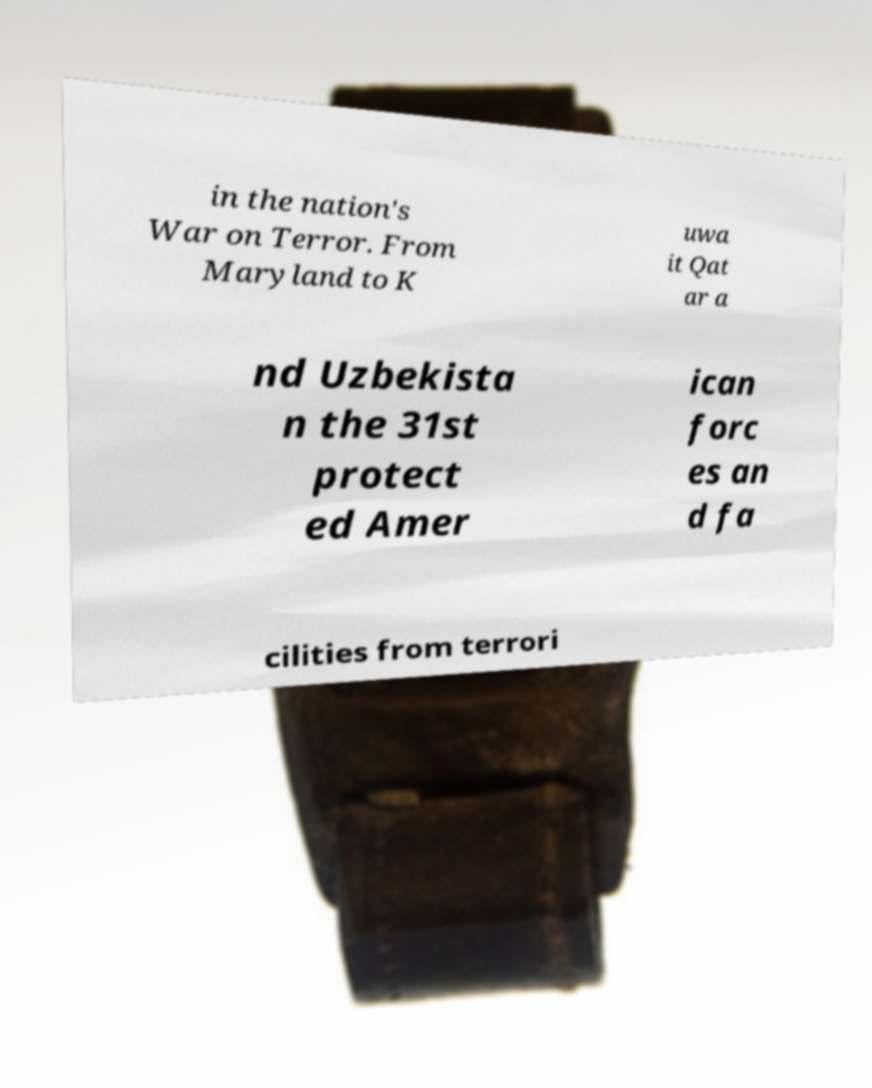Could you extract and type out the text from this image? in the nation's War on Terror. From Maryland to K uwa it Qat ar a nd Uzbekista n the 31st protect ed Amer ican forc es an d fa cilities from terrori 